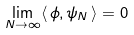<formula> <loc_0><loc_0><loc_500><loc_500>\lim _ { N \to \infty } \langle \, \phi , \psi _ { N } \, \rangle = 0</formula> 